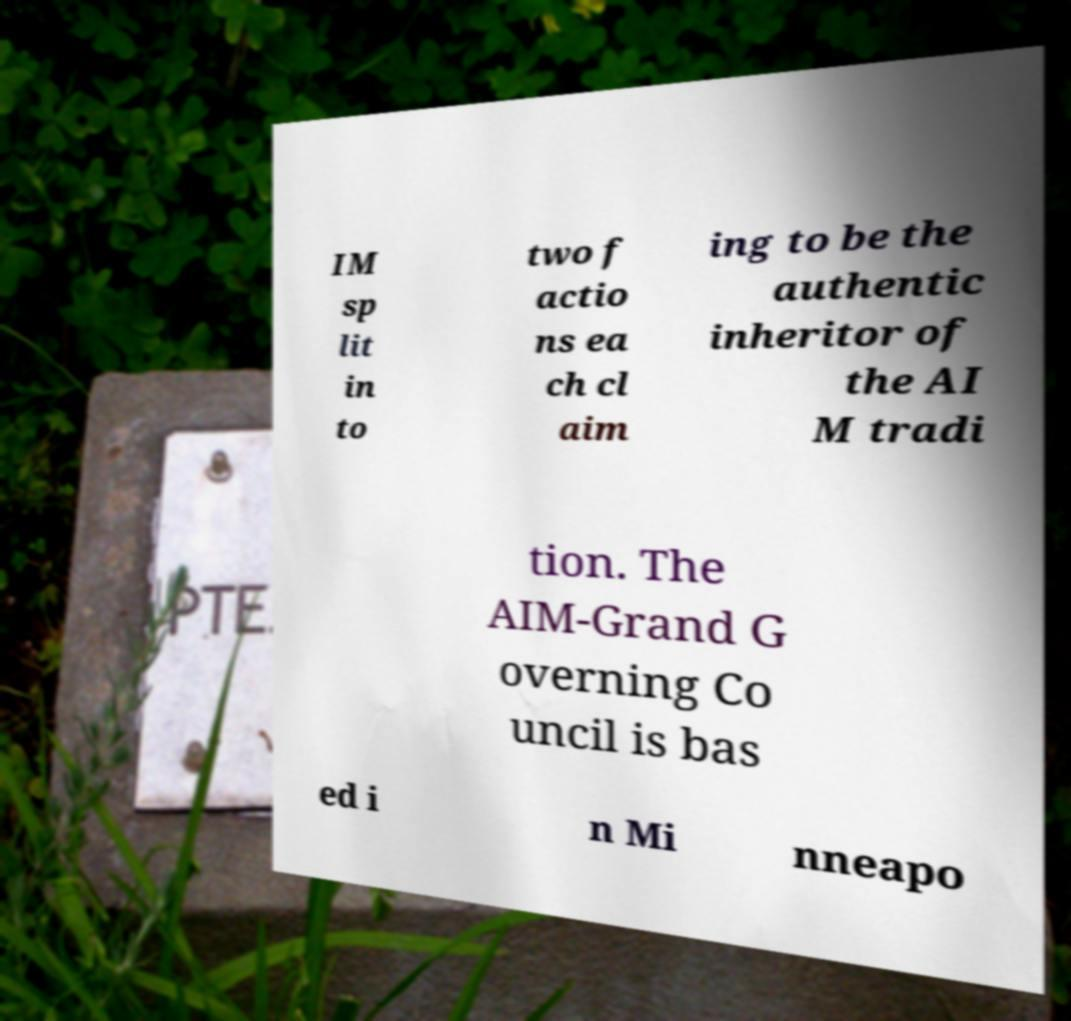There's text embedded in this image that I need extracted. Can you transcribe it verbatim? IM sp lit in to two f actio ns ea ch cl aim ing to be the authentic inheritor of the AI M tradi tion. The AIM-Grand G overning Co uncil is bas ed i n Mi nneapo 